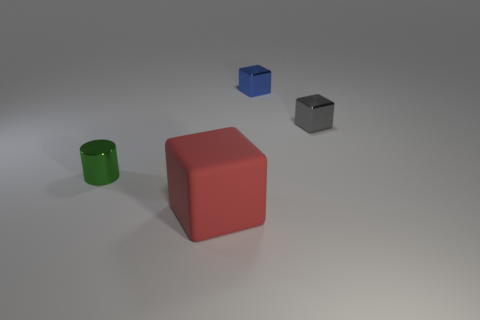Subtract all large red rubber blocks. How many blocks are left? 2 Subtract all blue blocks. How many blocks are left? 2 Subtract 1 cubes. How many cubes are left? 2 Add 2 brown matte balls. How many objects exist? 6 Subtract all blocks. How many objects are left? 1 Subtract all brown cubes. Subtract all brown balls. How many cubes are left? 3 Subtract all yellow blocks. How many blue cylinders are left? 0 Subtract all gray metallic cubes. Subtract all green shiny cylinders. How many objects are left? 2 Add 1 tiny gray metallic things. How many tiny gray metallic things are left? 2 Add 3 large green metallic blocks. How many large green metallic blocks exist? 3 